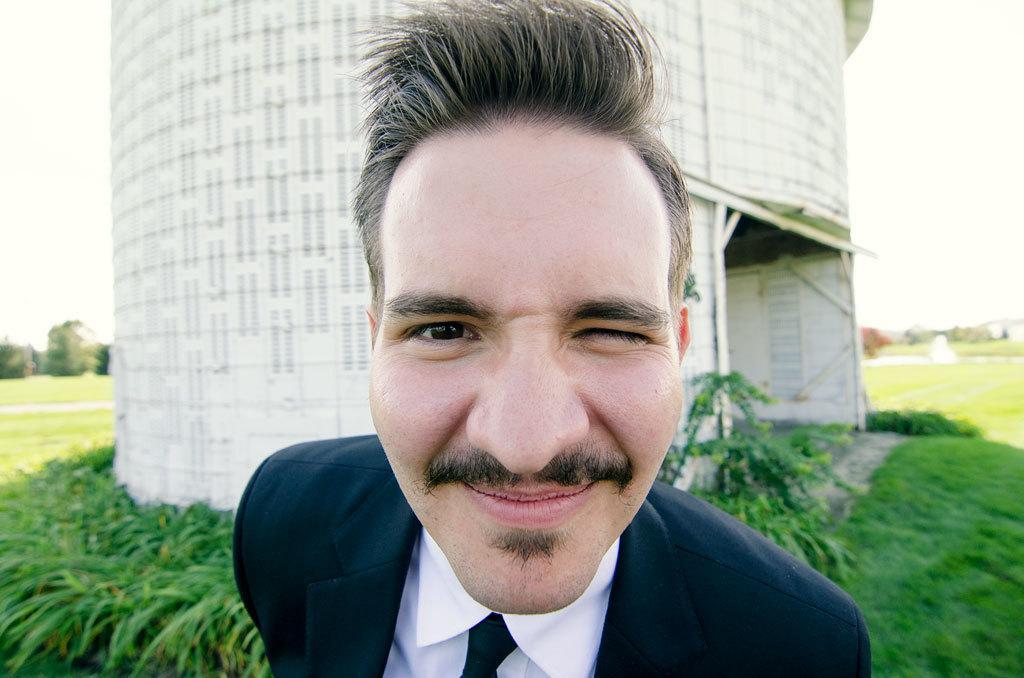How would you summarize this image in a sentence or two? In the middle of the image there is a man with black jacket, white shirt and tie. Behind him there is a tower. And on the ground there is grass. 